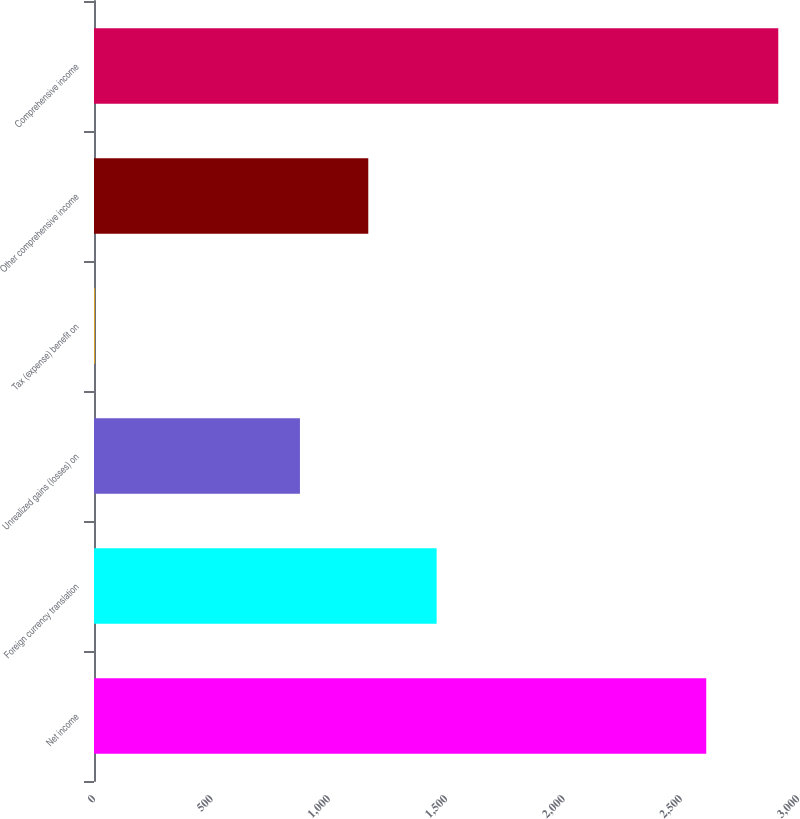Convert chart. <chart><loc_0><loc_0><loc_500><loc_500><bar_chart><fcel>Net income<fcel>Foreign currency translation<fcel>Unrealized gains (losses) on<fcel>Tax (expense) benefit on<fcel>Other comprehensive income<fcel>Comprehensive income<nl><fcel>2609<fcel>1460<fcel>877.6<fcel>4<fcel>1168.8<fcel>2916<nl></chart> 